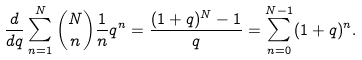<formula> <loc_0><loc_0><loc_500><loc_500>\frac { d } { d q } \sum _ { n = 1 } ^ { N } \binom { N } { n } \frac { 1 } { n } q ^ { n } = \frac { ( 1 + q ) ^ { N } - 1 } { q } = \sum _ { n = 0 } ^ { N - 1 } ( 1 + q ) ^ { n } .</formula> 